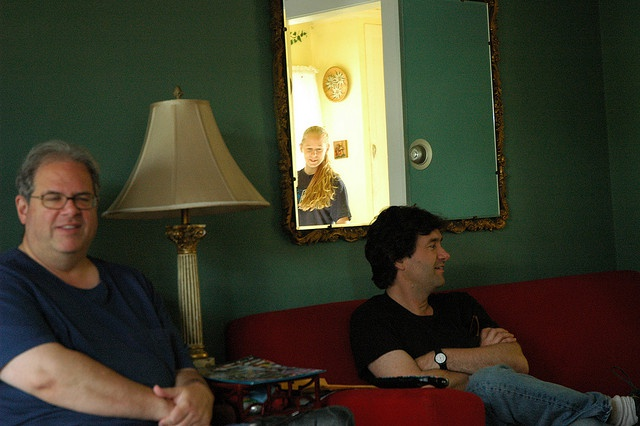Describe the objects in this image and their specific colors. I can see people in black, gray, and maroon tones, couch in black, maroon, and gray tones, people in black, maroon, and purple tones, people in black, tan, olive, and gray tones, and remote in black, gray, and maroon tones in this image. 